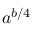<formula> <loc_0><loc_0><loc_500><loc_500>a ^ { b / 4 }</formula> 